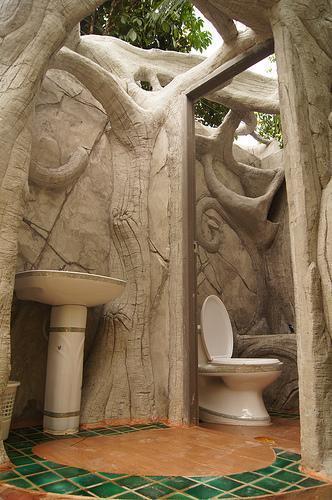How many sink on the restroom?
Give a very brief answer. 1. 